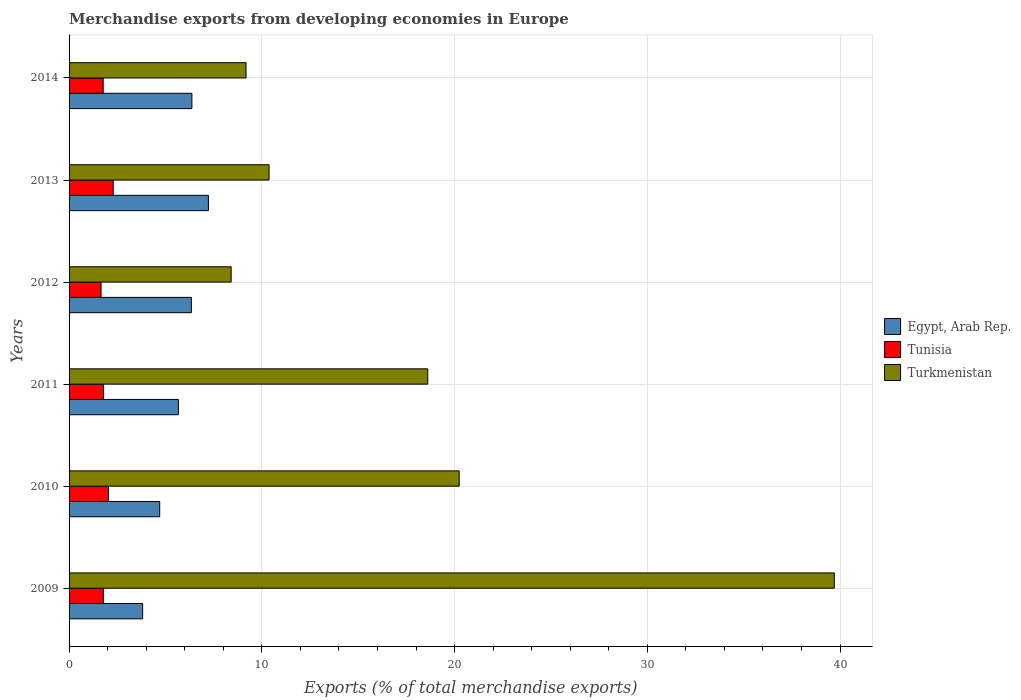Are the number of bars per tick equal to the number of legend labels?
Provide a short and direct response. Yes. How many bars are there on the 5th tick from the top?
Offer a very short reply. 3. How many bars are there on the 4th tick from the bottom?
Keep it short and to the point. 3. In how many cases, is the number of bars for a given year not equal to the number of legend labels?
Offer a very short reply. 0. What is the percentage of total merchandise exports in Egypt, Arab Rep. in 2013?
Offer a very short reply. 7.23. Across all years, what is the maximum percentage of total merchandise exports in Tunisia?
Your response must be concise. 2.29. Across all years, what is the minimum percentage of total merchandise exports in Tunisia?
Your answer should be compact. 1.66. What is the total percentage of total merchandise exports in Tunisia in the graph?
Keep it short and to the point. 11.33. What is the difference between the percentage of total merchandise exports in Egypt, Arab Rep. in 2009 and that in 2010?
Keep it short and to the point. -0.89. What is the difference between the percentage of total merchandise exports in Tunisia in 2010 and the percentage of total merchandise exports in Egypt, Arab Rep. in 2013?
Provide a short and direct response. -5.19. What is the average percentage of total merchandise exports in Egypt, Arab Rep. per year?
Your answer should be very brief. 5.69. In the year 2009, what is the difference between the percentage of total merchandise exports in Turkmenistan and percentage of total merchandise exports in Egypt, Arab Rep.?
Your response must be concise. 35.89. What is the ratio of the percentage of total merchandise exports in Turkmenistan in 2010 to that in 2014?
Offer a terse response. 2.2. Is the percentage of total merchandise exports in Turkmenistan in 2010 less than that in 2013?
Your answer should be very brief. No. What is the difference between the highest and the second highest percentage of total merchandise exports in Turkmenistan?
Give a very brief answer. 19.46. What is the difference between the highest and the lowest percentage of total merchandise exports in Egypt, Arab Rep.?
Provide a short and direct response. 3.41. What does the 3rd bar from the top in 2011 represents?
Keep it short and to the point. Egypt, Arab Rep. What does the 2nd bar from the bottom in 2009 represents?
Your answer should be compact. Tunisia. Is it the case that in every year, the sum of the percentage of total merchandise exports in Turkmenistan and percentage of total merchandise exports in Egypt, Arab Rep. is greater than the percentage of total merchandise exports in Tunisia?
Ensure brevity in your answer.  Yes. How many bars are there?
Your response must be concise. 18. Are all the bars in the graph horizontal?
Offer a terse response. Yes. What is the difference between two consecutive major ticks on the X-axis?
Offer a terse response. 10. Are the values on the major ticks of X-axis written in scientific E-notation?
Ensure brevity in your answer.  No. Does the graph contain any zero values?
Offer a terse response. No. Where does the legend appear in the graph?
Offer a terse response. Center right. How many legend labels are there?
Make the answer very short. 3. What is the title of the graph?
Make the answer very short. Merchandise exports from developing economies in Europe. What is the label or title of the X-axis?
Provide a short and direct response. Exports (% of total merchandise exports). What is the Exports (% of total merchandise exports) in Egypt, Arab Rep. in 2009?
Give a very brief answer. 3.82. What is the Exports (% of total merchandise exports) in Tunisia in 2009?
Give a very brief answer. 1.78. What is the Exports (% of total merchandise exports) in Turkmenistan in 2009?
Ensure brevity in your answer.  39.7. What is the Exports (% of total merchandise exports) in Egypt, Arab Rep. in 2010?
Your answer should be very brief. 4.7. What is the Exports (% of total merchandise exports) in Tunisia in 2010?
Offer a terse response. 2.04. What is the Exports (% of total merchandise exports) in Turkmenistan in 2010?
Your response must be concise. 20.24. What is the Exports (% of total merchandise exports) of Egypt, Arab Rep. in 2011?
Offer a very short reply. 5.67. What is the Exports (% of total merchandise exports) in Tunisia in 2011?
Your response must be concise. 1.79. What is the Exports (% of total merchandise exports) of Turkmenistan in 2011?
Provide a succinct answer. 18.61. What is the Exports (% of total merchandise exports) in Egypt, Arab Rep. in 2012?
Your answer should be very brief. 6.35. What is the Exports (% of total merchandise exports) of Tunisia in 2012?
Offer a very short reply. 1.66. What is the Exports (% of total merchandise exports) of Turkmenistan in 2012?
Provide a short and direct response. 8.41. What is the Exports (% of total merchandise exports) in Egypt, Arab Rep. in 2013?
Offer a very short reply. 7.23. What is the Exports (% of total merchandise exports) in Tunisia in 2013?
Offer a very short reply. 2.29. What is the Exports (% of total merchandise exports) in Turkmenistan in 2013?
Offer a terse response. 10.38. What is the Exports (% of total merchandise exports) of Egypt, Arab Rep. in 2014?
Your answer should be very brief. 6.37. What is the Exports (% of total merchandise exports) in Tunisia in 2014?
Offer a terse response. 1.77. What is the Exports (% of total merchandise exports) in Turkmenistan in 2014?
Provide a short and direct response. 9.18. Across all years, what is the maximum Exports (% of total merchandise exports) of Egypt, Arab Rep.?
Your answer should be very brief. 7.23. Across all years, what is the maximum Exports (% of total merchandise exports) of Tunisia?
Give a very brief answer. 2.29. Across all years, what is the maximum Exports (% of total merchandise exports) of Turkmenistan?
Give a very brief answer. 39.7. Across all years, what is the minimum Exports (% of total merchandise exports) of Egypt, Arab Rep.?
Provide a succinct answer. 3.82. Across all years, what is the minimum Exports (% of total merchandise exports) of Tunisia?
Ensure brevity in your answer.  1.66. Across all years, what is the minimum Exports (% of total merchandise exports) of Turkmenistan?
Offer a very short reply. 8.41. What is the total Exports (% of total merchandise exports) of Egypt, Arab Rep. in the graph?
Keep it short and to the point. 34.14. What is the total Exports (% of total merchandise exports) in Tunisia in the graph?
Offer a very short reply. 11.33. What is the total Exports (% of total merchandise exports) of Turkmenistan in the graph?
Make the answer very short. 106.52. What is the difference between the Exports (% of total merchandise exports) in Egypt, Arab Rep. in 2009 and that in 2010?
Provide a succinct answer. -0.89. What is the difference between the Exports (% of total merchandise exports) in Tunisia in 2009 and that in 2010?
Ensure brevity in your answer.  -0.27. What is the difference between the Exports (% of total merchandise exports) in Turkmenistan in 2009 and that in 2010?
Make the answer very short. 19.46. What is the difference between the Exports (% of total merchandise exports) of Egypt, Arab Rep. in 2009 and that in 2011?
Ensure brevity in your answer.  -1.86. What is the difference between the Exports (% of total merchandise exports) in Tunisia in 2009 and that in 2011?
Make the answer very short. -0.01. What is the difference between the Exports (% of total merchandise exports) of Turkmenistan in 2009 and that in 2011?
Provide a succinct answer. 21.09. What is the difference between the Exports (% of total merchandise exports) of Egypt, Arab Rep. in 2009 and that in 2012?
Give a very brief answer. -2.53. What is the difference between the Exports (% of total merchandise exports) of Tunisia in 2009 and that in 2012?
Offer a very short reply. 0.12. What is the difference between the Exports (% of total merchandise exports) in Turkmenistan in 2009 and that in 2012?
Provide a short and direct response. 31.29. What is the difference between the Exports (% of total merchandise exports) of Egypt, Arab Rep. in 2009 and that in 2013?
Provide a succinct answer. -3.41. What is the difference between the Exports (% of total merchandise exports) of Tunisia in 2009 and that in 2013?
Your answer should be compact. -0.51. What is the difference between the Exports (% of total merchandise exports) in Turkmenistan in 2009 and that in 2013?
Your answer should be compact. 29.33. What is the difference between the Exports (% of total merchandise exports) of Egypt, Arab Rep. in 2009 and that in 2014?
Your answer should be compact. -2.56. What is the difference between the Exports (% of total merchandise exports) in Tunisia in 2009 and that in 2014?
Your answer should be very brief. 0.01. What is the difference between the Exports (% of total merchandise exports) in Turkmenistan in 2009 and that in 2014?
Keep it short and to the point. 30.52. What is the difference between the Exports (% of total merchandise exports) in Egypt, Arab Rep. in 2010 and that in 2011?
Offer a terse response. -0.97. What is the difference between the Exports (% of total merchandise exports) of Tunisia in 2010 and that in 2011?
Make the answer very short. 0.25. What is the difference between the Exports (% of total merchandise exports) in Turkmenistan in 2010 and that in 2011?
Your answer should be very brief. 1.63. What is the difference between the Exports (% of total merchandise exports) of Egypt, Arab Rep. in 2010 and that in 2012?
Your answer should be very brief. -1.64. What is the difference between the Exports (% of total merchandise exports) of Tunisia in 2010 and that in 2012?
Give a very brief answer. 0.38. What is the difference between the Exports (% of total merchandise exports) in Turkmenistan in 2010 and that in 2012?
Your response must be concise. 11.83. What is the difference between the Exports (% of total merchandise exports) in Egypt, Arab Rep. in 2010 and that in 2013?
Provide a succinct answer. -2.53. What is the difference between the Exports (% of total merchandise exports) in Tunisia in 2010 and that in 2013?
Keep it short and to the point. -0.25. What is the difference between the Exports (% of total merchandise exports) of Turkmenistan in 2010 and that in 2013?
Make the answer very short. 9.86. What is the difference between the Exports (% of total merchandise exports) of Egypt, Arab Rep. in 2010 and that in 2014?
Provide a succinct answer. -1.67. What is the difference between the Exports (% of total merchandise exports) in Tunisia in 2010 and that in 2014?
Your answer should be very brief. 0.27. What is the difference between the Exports (% of total merchandise exports) in Turkmenistan in 2010 and that in 2014?
Keep it short and to the point. 11.06. What is the difference between the Exports (% of total merchandise exports) of Egypt, Arab Rep. in 2011 and that in 2012?
Your answer should be compact. -0.67. What is the difference between the Exports (% of total merchandise exports) of Tunisia in 2011 and that in 2012?
Ensure brevity in your answer.  0.13. What is the difference between the Exports (% of total merchandise exports) in Turkmenistan in 2011 and that in 2012?
Your answer should be compact. 10.2. What is the difference between the Exports (% of total merchandise exports) of Egypt, Arab Rep. in 2011 and that in 2013?
Offer a terse response. -1.56. What is the difference between the Exports (% of total merchandise exports) in Tunisia in 2011 and that in 2013?
Give a very brief answer. -0.5. What is the difference between the Exports (% of total merchandise exports) in Turkmenistan in 2011 and that in 2013?
Offer a very short reply. 8.23. What is the difference between the Exports (% of total merchandise exports) of Egypt, Arab Rep. in 2011 and that in 2014?
Your answer should be compact. -0.7. What is the difference between the Exports (% of total merchandise exports) of Tunisia in 2011 and that in 2014?
Make the answer very short. 0.02. What is the difference between the Exports (% of total merchandise exports) in Turkmenistan in 2011 and that in 2014?
Provide a short and direct response. 9.43. What is the difference between the Exports (% of total merchandise exports) of Egypt, Arab Rep. in 2012 and that in 2013?
Give a very brief answer. -0.88. What is the difference between the Exports (% of total merchandise exports) of Tunisia in 2012 and that in 2013?
Give a very brief answer. -0.63. What is the difference between the Exports (% of total merchandise exports) of Turkmenistan in 2012 and that in 2013?
Your response must be concise. -1.97. What is the difference between the Exports (% of total merchandise exports) in Egypt, Arab Rep. in 2012 and that in 2014?
Provide a short and direct response. -0.03. What is the difference between the Exports (% of total merchandise exports) of Tunisia in 2012 and that in 2014?
Make the answer very short. -0.11. What is the difference between the Exports (% of total merchandise exports) in Turkmenistan in 2012 and that in 2014?
Provide a short and direct response. -0.77. What is the difference between the Exports (% of total merchandise exports) in Egypt, Arab Rep. in 2013 and that in 2014?
Give a very brief answer. 0.86. What is the difference between the Exports (% of total merchandise exports) of Tunisia in 2013 and that in 2014?
Your answer should be very brief. 0.52. What is the difference between the Exports (% of total merchandise exports) in Turkmenistan in 2013 and that in 2014?
Provide a succinct answer. 1.2. What is the difference between the Exports (% of total merchandise exports) in Egypt, Arab Rep. in 2009 and the Exports (% of total merchandise exports) in Tunisia in 2010?
Give a very brief answer. 1.77. What is the difference between the Exports (% of total merchandise exports) of Egypt, Arab Rep. in 2009 and the Exports (% of total merchandise exports) of Turkmenistan in 2010?
Provide a short and direct response. -16.42. What is the difference between the Exports (% of total merchandise exports) of Tunisia in 2009 and the Exports (% of total merchandise exports) of Turkmenistan in 2010?
Give a very brief answer. -18.46. What is the difference between the Exports (% of total merchandise exports) of Egypt, Arab Rep. in 2009 and the Exports (% of total merchandise exports) of Tunisia in 2011?
Offer a terse response. 2.03. What is the difference between the Exports (% of total merchandise exports) of Egypt, Arab Rep. in 2009 and the Exports (% of total merchandise exports) of Turkmenistan in 2011?
Give a very brief answer. -14.79. What is the difference between the Exports (% of total merchandise exports) of Tunisia in 2009 and the Exports (% of total merchandise exports) of Turkmenistan in 2011?
Give a very brief answer. -16.83. What is the difference between the Exports (% of total merchandise exports) in Egypt, Arab Rep. in 2009 and the Exports (% of total merchandise exports) in Tunisia in 2012?
Offer a terse response. 2.16. What is the difference between the Exports (% of total merchandise exports) in Egypt, Arab Rep. in 2009 and the Exports (% of total merchandise exports) in Turkmenistan in 2012?
Make the answer very short. -4.59. What is the difference between the Exports (% of total merchandise exports) of Tunisia in 2009 and the Exports (% of total merchandise exports) of Turkmenistan in 2012?
Offer a very short reply. -6.63. What is the difference between the Exports (% of total merchandise exports) of Egypt, Arab Rep. in 2009 and the Exports (% of total merchandise exports) of Tunisia in 2013?
Provide a succinct answer. 1.53. What is the difference between the Exports (% of total merchandise exports) in Egypt, Arab Rep. in 2009 and the Exports (% of total merchandise exports) in Turkmenistan in 2013?
Provide a short and direct response. -6.56. What is the difference between the Exports (% of total merchandise exports) of Egypt, Arab Rep. in 2009 and the Exports (% of total merchandise exports) of Tunisia in 2014?
Provide a succinct answer. 2.05. What is the difference between the Exports (% of total merchandise exports) in Egypt, Arab Rep. in 2009 and the Exports (% of total merchandise exports) in Turkmenistan in 2014?
Provide a short and direct response. -5.36. What is the difference between the Exports (% of total merchandise exports) in Tunisia in 2009 and the Exports (% of total merchandise exports) in Turkmenistan in 2014?
Keep it short and to the point. -7.4. What is the difference between the Exports (% of total merchandise exports) in Egypt, Arab Rep. in 2010 and the Exports (% of total merchandise exports) in Tunisia in 2011?
Your answer should be compact. 2.91. What is the difference between the Exports (% of total merchandise exports) in Egypt, Arab Rep. in 2010 and the Exports (% of total merchandise exports) in Turkmenistan in 2011?
Your answer should be very brief. -13.91. What is the difference between the Exports (% of total merchandise exports) of Tunisia in 2010 and the Exports (% of total merchandise exports) of Turkmenistan in 2011?
Offer a very short reply. -16.57. What is the difference between the Exports (% of total merchandise exports) in Egypt, Arab Rep. in 2010 and the Exports (% of total merchandise exports) in Tunisia in 2012?
Offer a terse response. 3.04. What is the difference between the Exports (% of total merchandise exports) of Egypt, Arab Rep. in 2010 and the Exports (% of total merchandise exports) of Turkmenistan in 2012?
Provide a short and direct response. -3.71. What is the difference between the Exports (% of total merchandise exports) in Tunisia in 2010 and the Exports (% of total merchandise exports) in Turkmenistan in 2012?
Make the answer very short. -6.37. What is the difference between the Exports (% of total merchandise exports) in Egypt, Arab Rep. in 2010 and the Exports (% of total merchandise exports) in Tunisia in 2013?
Your response must be concise. 2.41. What is the difference between the Exports (% of total merchandise exports) of Egypt, Arab Rep. in 2010 and the Exports (% of total merchandise exports) of Turkmenistan in 2013?
Your response must be concise. -5.67. What is the difference between the Exports (% of total merchandise exports) of Tunisia in 2010 and the Exports (% of total merchandise exports) of Turkmenistan in 2013?
Your answer should be compact. -8.33. What is the difference between the Exports (% of total merchandise exports) in Egypt, Arab Rep. in 2010 and the Exports (% of total merchandise exports) in Tunisia in 2014?
Provide a succinct answer. 2.93. What is the difference between the Exports (% of total merchandise exports) in Egypt, Arab Rep. in 2010 and the Exports (% of total merchandise exports) in Turkmenistan in 2014?
Ensure brevity in your answer.  -4.48. What is the difference between the Exports (% of total merchandise exports) of Tunisia in 2010 and the Exports (% of total merchandise exports) of Turkmenistan in 2014?
Keep it short and to the point. -7.14. What is the difference between the Exports (% of total merchandise exports) of Egypt, Arab Rep. in 2011 and the Exports (% of total merchandise exports) of Tunisia in 2012?
Ensure brevity in your answer.  4.01. What is the difference between the Exports (% of total merchandise exports) in Egypt, Arab Rep. in 2011 and the Exports (% of total merchandise exports) in Turkmenistan in 2012?
Your response must be concise. -2.74. What is the difference between the Exports (% of total merchandise exports) of Tunisia in 2011 and the Exports (% of total merchandise exports) of Turkmenistan in 2012?
Provide a short and direct response. -6.62. What is the difference between the Exports (% of total merchandise exports) in Egypt, Arab Rep. in 2011 and the Exports (% of total merchandise exports) in Tunisia in 2013?
Offer a very short reply. 3.38. What is the difference between the Exports (% of total merchandise exports) in Egypt, Arab Rep. in 2011 and the Exports (% of total merchandise exports) in Turkmenistan in 2013?
Offer a very short reply. -4.7. What is the difference between the Exports (% of total merchandise exports) in Tunisia in 2011 and the Exports (% of total merchandise exports) in Turkmenistan in 2013?
Make the answer very short. -8.59. What is the difference between the Exports (% of total merchandise exports) in Egypt, Arab Rep. in 2011 and the Exports (% of total merchandise exports) in Tunisia in 2014?
Keep it short and to the point. 3.9. What is the difference between the Exports (% of total merchandise exports) of Egypt, Arab Rep. in 2011 and the Exports (% of total merchandise exports) of Turkmenistan in 2014?
Offer a terse response. -3.51. What is the difference between the Exports (% of total merchandise exports) of Tunisia in 2011 and the Exports (% of total merchandise exports) of Turkmenistan in 2014?
Give a very brief answer. -7.39. What is the difference between the Exports (% of total merchandise exports) in Egypt, Arab Rep. in 2012 and the Exports (% of total merchandise exports) in Tunisia in 2013?
Provide a short and direct response. 4.06. What is the difference between the Exports (% of total merchandise exports) in Egypt, Arab Rep. in 2012 and the Exports (% of total merchandise exports) in Turkmenistan in 2013?
Offer a very short reply. -4.03. What is the difference between the Exports (% of total merchandise exports) of Tunisia in 2012 and the Exports (% of total merchandise exports) of Turkmenistan in 2013?
Provide a short and direct response. -8.72. What is the difference between the Exports (% of total merchandise exports) of Egypt, Arab Rep. in 2012 and the Exports (% of total merchandise exports) of Tunisia in 2014?
Your answer should be compact. 4.58. What is the difference between the Exports (% of total merchandise exports) of Egypt, Arab Rep. in 2012 and the Exports (% of total merchandise exports) of Turkmenistan in 2014?
Give a very brief answer. -2.84. What is the difference between the Exports (% of total merchandise exports) in Tunisia in 2012 and the Exports (% of total merchandise exports) in Turkmenistan in 2014?
Keep it short and to the point. -7.52. What is the difference between the Exports (% of total merchandise exports) in Egypt, Arab Rep. in 2013 and the Exports (% of total merchandise exports) in Tunisia in 2014?
Your answer should be very brief. 5.46. What is the difference between the Exports (% of total merchandise exports) in Egypt, Arab Rep. in 2013 and the Exports (% of total merchandise exports) in Turkmenistan in 2014?
Your response must be concise. -1.95. What is the difference between the Exports (% of total merchandise exports) in Tunisia in 2013 and the Exports (% of total merchandise exports) in Turkmenistan in 2014?
Your answer should be very brief. -6.89. What is the average Exports (% of total merchandise exports) in Egypt, Arab Rep. per year?
Provide a short and direct response. 5.69. What is the average Exports (% of total merchandise exports) of Tunisia per year?
Keep it short and to the point. 1.89. What is the average Exports (% of total merchandise exports) in Turkmenistan per year?
Offer a terse response. 17.75. In the year 2009, what is the difference between the Exports (% of total merchandise exports) in Egypt, Arab Rep. and Exports (% of total merchandise exports) in Tunisia?
Make the answer very short. 2.04. In the year 2009, what is the difference between the Exports (% of total merchandise exports) in Egypt, Arab Rep. and Exports (% of total merchandise exports) in Turkmenistan?
Give a very brief answer. -35.89. In the year 2009, what is the difference between the Exports (% of total merchandise exports) in Tunisia and Exports (% of total merchandise exports) in Turkmenistan?
Keep it short and to the point. -37.93. In the year 2010, what is the difference between the Exports (% of total merchandise exports) of Egypt, Arab Rep. and Exports (% of total merchandise exports) of Tunisia?
Offer a very short reply. 2.66. In the year 2010, what is the difference between the Exports (% of total merchandise exports) of Egypt, Arab Rep. and Exports (% of total merchandise exports) of Turkmenistan?
Provide a short and direct response. -15.54. In the year 2010, what is the difference between the Exports (% of total merchandise exports) of Tunisia and Exports (% of total merchandise exports) of Turkmenistan?
Offer a terse response. -18.2. In the year 2011, what is the difference between the Exports (% of total merchandise exports) of Egypt, Arab Rep. and Exports (% of total merchandise exports) of Tunisia?
Your response must be concise. 3.88. In the year 2011, what is the difference between the Exports (% of total merchandise exports) of Egypt, Arab Rep. and Exports (% of total merchandise exports) of Turkmenistan?
Provide a short and direct response. -12.94. In the year 2011, what is the difference between the Exports (% of total merchandise exports) in Tunisia and Exports (% of total merchandise exports) in Turkmenistan?
Offer a very short reply. -16.82. In the year 2012, what is the difference between the Exports (% of total merchandise exports) of Egypt, Arab Rep. and Exports (% of total merchandise exports) of Tunisia?
Provide a succinct answer. 4.69. In the year 2012, what is the difference between the Exports (% of total merchandise exports) of Egypt, Arab Rep. and Exports (% of total merchandise exports) of Turkmenistan?
Provide a succinct answer. -2.06. In the year 2012, what is the difference between the Exports (% of total merchandise exports) of Tunisia and Exports (% of total merchandise exports) of Turkmenistan?
Provide a succinct answer. -6.75. In the year 2013, what is the difference between the Exports (% of total merchandise exports) of Egypt, Arab Rep. and Exports (% of total merchandise exports) of Tunisia?
Give a very brief answer. 4.94. In the year 2013, what is the difference between the Exports (% of total merchandise exports) in Egypt, Arab Rep. and Exports (% of total merchandise exports) in Turkmenistan?
Provide a short and direct response. -3.15. In the year 2013, what is the difference between the Exports (% of total merchandise exports) in Tunisia and Exports (% of total merchandise exports) in Turkmenistan?
Keep it short and to the point. -8.09. In the year 2014, what is the difference between the Exports (% of total merchandise exports) in Egypt, Arab Rep. and Exports (% of total merchandise exports) in Tunisia?
Keep it short and to the point. 4.6. In the year 2014, what is the difference between the Exports (% of total merchandise exports) of Egypt, Arab Rep. and Exports (% of total merchandise exports) of Turkmenistan?
Give a very brief answer. -2.81. In the year 2014, what is the difference between the Exports (% of total merchandise exports) of Tunisia and Exports (% of total merchandise exports) of Turkmenistan?
Give a very brief answer. -7.41. What is the ratio of the Exports (% of total merchandise exports) of Egypt, Arab Rep. in 2009 to that in 2010?
Make the answer very short. 0.81. What is the ratio of the Exports (% of total merchandise exports) of Tunisia in 2009 to that in 2010?
Provide a succinct answer. 0.87. What is the ratio of the Exports (% of total merchandise exports) in Turkmenistan in 2009 to that in 2010?
Your answer should be very brief. 1.96. What is the ratio of the Exports (% of total merchandise exports) of Egypt, Arab Rep. in 2009 to that in 2011?
Ensure brevity in your answer.  0.67. What is the ratio of the Exports (% of total merchandise exports) of Turkmenistan in 2009 to that in 2011?
Ensure brevity in your answer.  2.13. What is the ratio of the Exports (% of total merchandise exports) of Egypt, Arab Rep. in 2009 to that in 2012?
Ensure brevity in your answer.  0.6. What is the ratio of the Exports (% of total merchandise exports) of Tunisia in 2009 to that in 2012?
Give a very brief answer. 1.07. What is the ratio of the Exports (% of total merchandise exports) of Turkmenistan in 2009 to that in 2012?
Offer a terse response. 4.72. What is the ratio of the Exports (% of total merchandise exports) of Egypt, Arab Rep. in 2009 to that in 2013?
Offer a very short reply. 0.53. What is the ratio of the Exports (% of total merchandise exports) in Tunisia in 2009 to that in 2013?
Provide a succinct answer. 0.78. What is the ratio of the Exports (% of total merchandise exports) in Turkmenistan in 2009 to that in 2013?
Provide a short and direct response. 3.83. What is the ratio of the Exports (% of total merchandise exports) of Egypt, Arab Rep. in 2009 to that in 2014?
Your answer should be compact. 0.6. What is the ratio of the Exports (% of total merchandise exports) of Tunisia in 2009 to that in 2014?
Your response must be concise. 1. What is the ratio of the Exports (% of total merchandise exports) of Turkmenistan in 2009 to that in 2014?
Provide a short and direct response. 4.32. What is the ratio of the Exports (% of total merchandise exports) of Egypt, Arab Rep. in 2010 to that in 2011?
Ensure brevity in your answer.  0.83. What is the ratio of the Exports (% of total merchandise exports) in Tunisia in 2010 to that in 2011?
Your answer should be very brief. 1.14. What is the ratio of the Exports (% of total merchandise exports) of Turkmenistan in 2010 to that in 2011?
Offer a very short reply. 1.09. What is the ratio of the Exports (% of total merchandise exports) in Egypt, Arab Rep. in 2010 to that in 2012?
Your answer should be compact. 0.74. What is the ratio of the Exports (% of total merchandise exports) of Tunisia in 2010 to that in 2012?
Keep it short and to the point. 1.23. What is the ratio of the Exports (% of total merchandise exports) in Turkmenistan in 2010 to that in 2012?
Make the answer very short. 2.41. What is the ratio of the Exports (% of total merchandise exports) of Egypt, Arab Rep. in 2010 to that in 2013?
Provide a short and direct response. 0.65. What is the ratio of the Exports (% of total merchandise exports) of Tunisia in 2010 to that in 2013?
Your answer should be compact. 0.89. What is the ratio of the Exports (% of total merchandise exports) in Turkmenistan in 2010 to that in 2013?
Provide a succinct answer. 1.95. What is the ratio of the Exports (% of total merchandise exports) in Egypt, Arab Rep. in 2010 to that in 2014?
Your answer should be compact. 0.74. What is the ratio of the Exports (% of total merchandise exports) in Tunisia in 2010 to that in 2014?
Your response must be concise. 1.15. What is the ratio of the Exports (% of total merchandise exports) of Turkmenistan in 2010 to that in 2014?
Offer a very short reply. 2.2. What is the ratio of the Exports (% of total merchandise exports) of Egypt, Arab Rep. in 2011 to that in 2012?
Your answer should be very brief. 0.89. What is the ratio of the Exports (% of total merchandise exports) in Tunisia in 2011 to that in 2012?
Your response must be concise. 1.08. What is the ratio of the Exports (% of total merchandise exports) of Turkmenistan in 2011 to that in 2012?
Offer a terse response. 2.21. What is the ratio of the Exports (% of total merchandise exports) in Egypt, Arab Rep. in 2011 to that in 2013?
Keep it short and to the point. 0.78. What is the ratio of the Exports (% of total merchandise exports) of Tunisia in 2011 to that in 2013?
Keep it short and to the point. 0.78. What is the ratio of the Exports (% of total merchandise exports) in Turkmenistan in 2011 to that in 2013?
Provide a succinct answer. 1.79. What is the ratio of the Exports (% of total merchandise exports) of Egypt, Arab Rep. in 2011 to that in 2014?
Keep it short and to the point. 0.89. What is the ratio of the Exports (% of total merchandise exports) in Tunisia in 2011 to that in 2014?
Your answer should be very brief. 1.01. What is the ratio of the Exports (% of total merchandise exports) of Turkmenistan in 2011 to that in 2014?
Ensure brevity in your answer.  2.03. What is the ratio of the Exports (% of total merchandise exports) in Egypt, Arab Rep. in 2012 to that in 2013?
Offer a very short reply. 0.88. What is the ratio of the Exports (% of total merchandise exports) of Tunisia in 2012 to that in 2013?
Give a very brief answer. 0.72. What is the ratio of the Exports (% of total merchandise exports) of Turkmenistan in 2012 to that in 2013?
Your response must be concise. 0.81. What is the ratio of the Exports (% of total merchandise exports) in Egypt, Arab Rep. in 2012 to that in 2014?
Your answer should be compact. 1. What is the ratio of the Exports (% of total merchandise exports) in Tunisia in 2012 to that in 2014?
Provide a short and direct response. 0.94. What is the ratio of the Exports (% of total merchandise exports) of Turkmenistan in 2012 to that in 2014?
Give a very brief answer. 0.92. What is the ratio of the Exports (% of total merchandise exports) in Egypt, Arab Rep. in 2013 to that in 2014?
Provide a short and direct response. 1.13. What is the ratio of the Exports (% of total merchandise exports) of Tunisia in 2013 to that in 2014?
Provide a succinct answer. 1.29. What is the ratio of the Exports (% of total merchandise exports) in Turkmenistan in 2013 to that in 2014?
Give a very brief answer. 1.13. What is the difference between the highest and the second highest Exports (% of total merchandise exports) in Egypt, Arab Rep.?
Give a very brief answer. 0.86. What is the difference between the highest and the second highest Exports (% of total merchandise exports) in Tunisia?
Offer a terse response. 0.25. What is the difference between the highest and the second highest Exports (% of total merchandise exports) of Turkmenistan?
Offer a very short reply. 19.46. What is the difference between the highest and the lowest Exports (% of total merchandise exports) in Egypt, Arab Rep.?
Offer a very short reply. 3.41. What is the difference between the highest and the lowest Exports (% of total merchandise exports) in Tunisia?
Give a very brief answer. 0.63. What is the difference between the highest and the lowest Exports (% of total merchandise exports) in Turkmenistan?
Offer a very short reply. 31.29. 